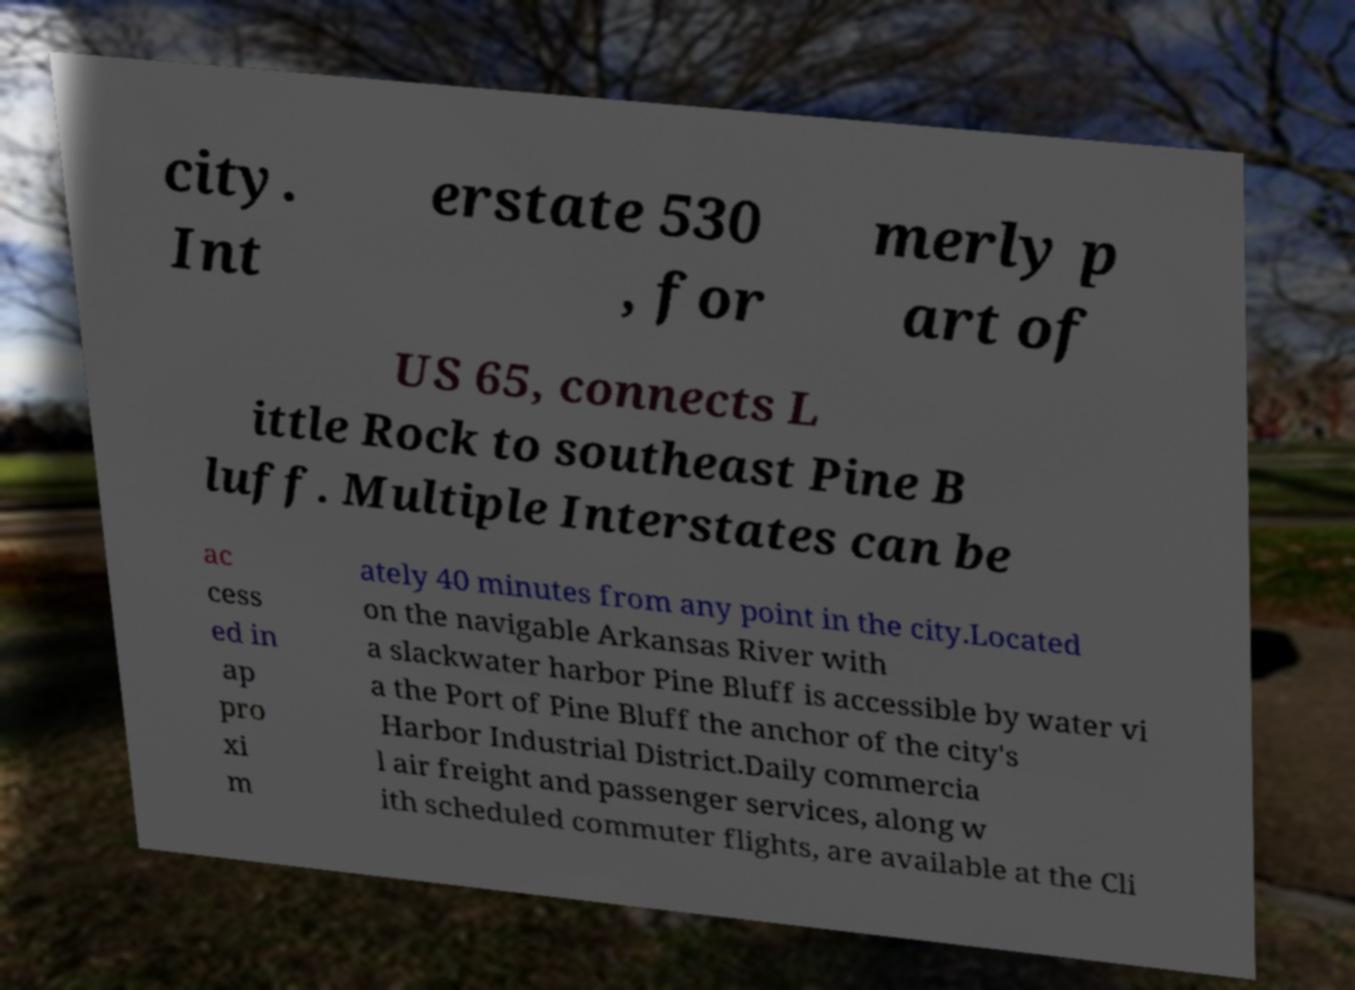For documentation purposes, I need the text within this image transcribed. Could you provide that? city. Int erstate 530 , for merly p art of US 65, connects L ittle Rock to southeast Pine B luff. Multiple Interstates can be ac cess ed in ap pro xi m ately 40 minutes from any point in the city.Located on the navigable Arkansas River with a slackwater harbor Pine Bluff is accessible by water vi a the Port of Pine Bluff the anchor of the city's Harbor Industrial District.Daily commercia l air freight and passenger services, along w ith scheduled commuter flights, are available at the Cli 